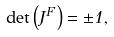<formula> <loc_0><loc_0><loc_500><loc_500>\det \left ( J ^ { F } \right ) = \pm 1 ,</formula> 